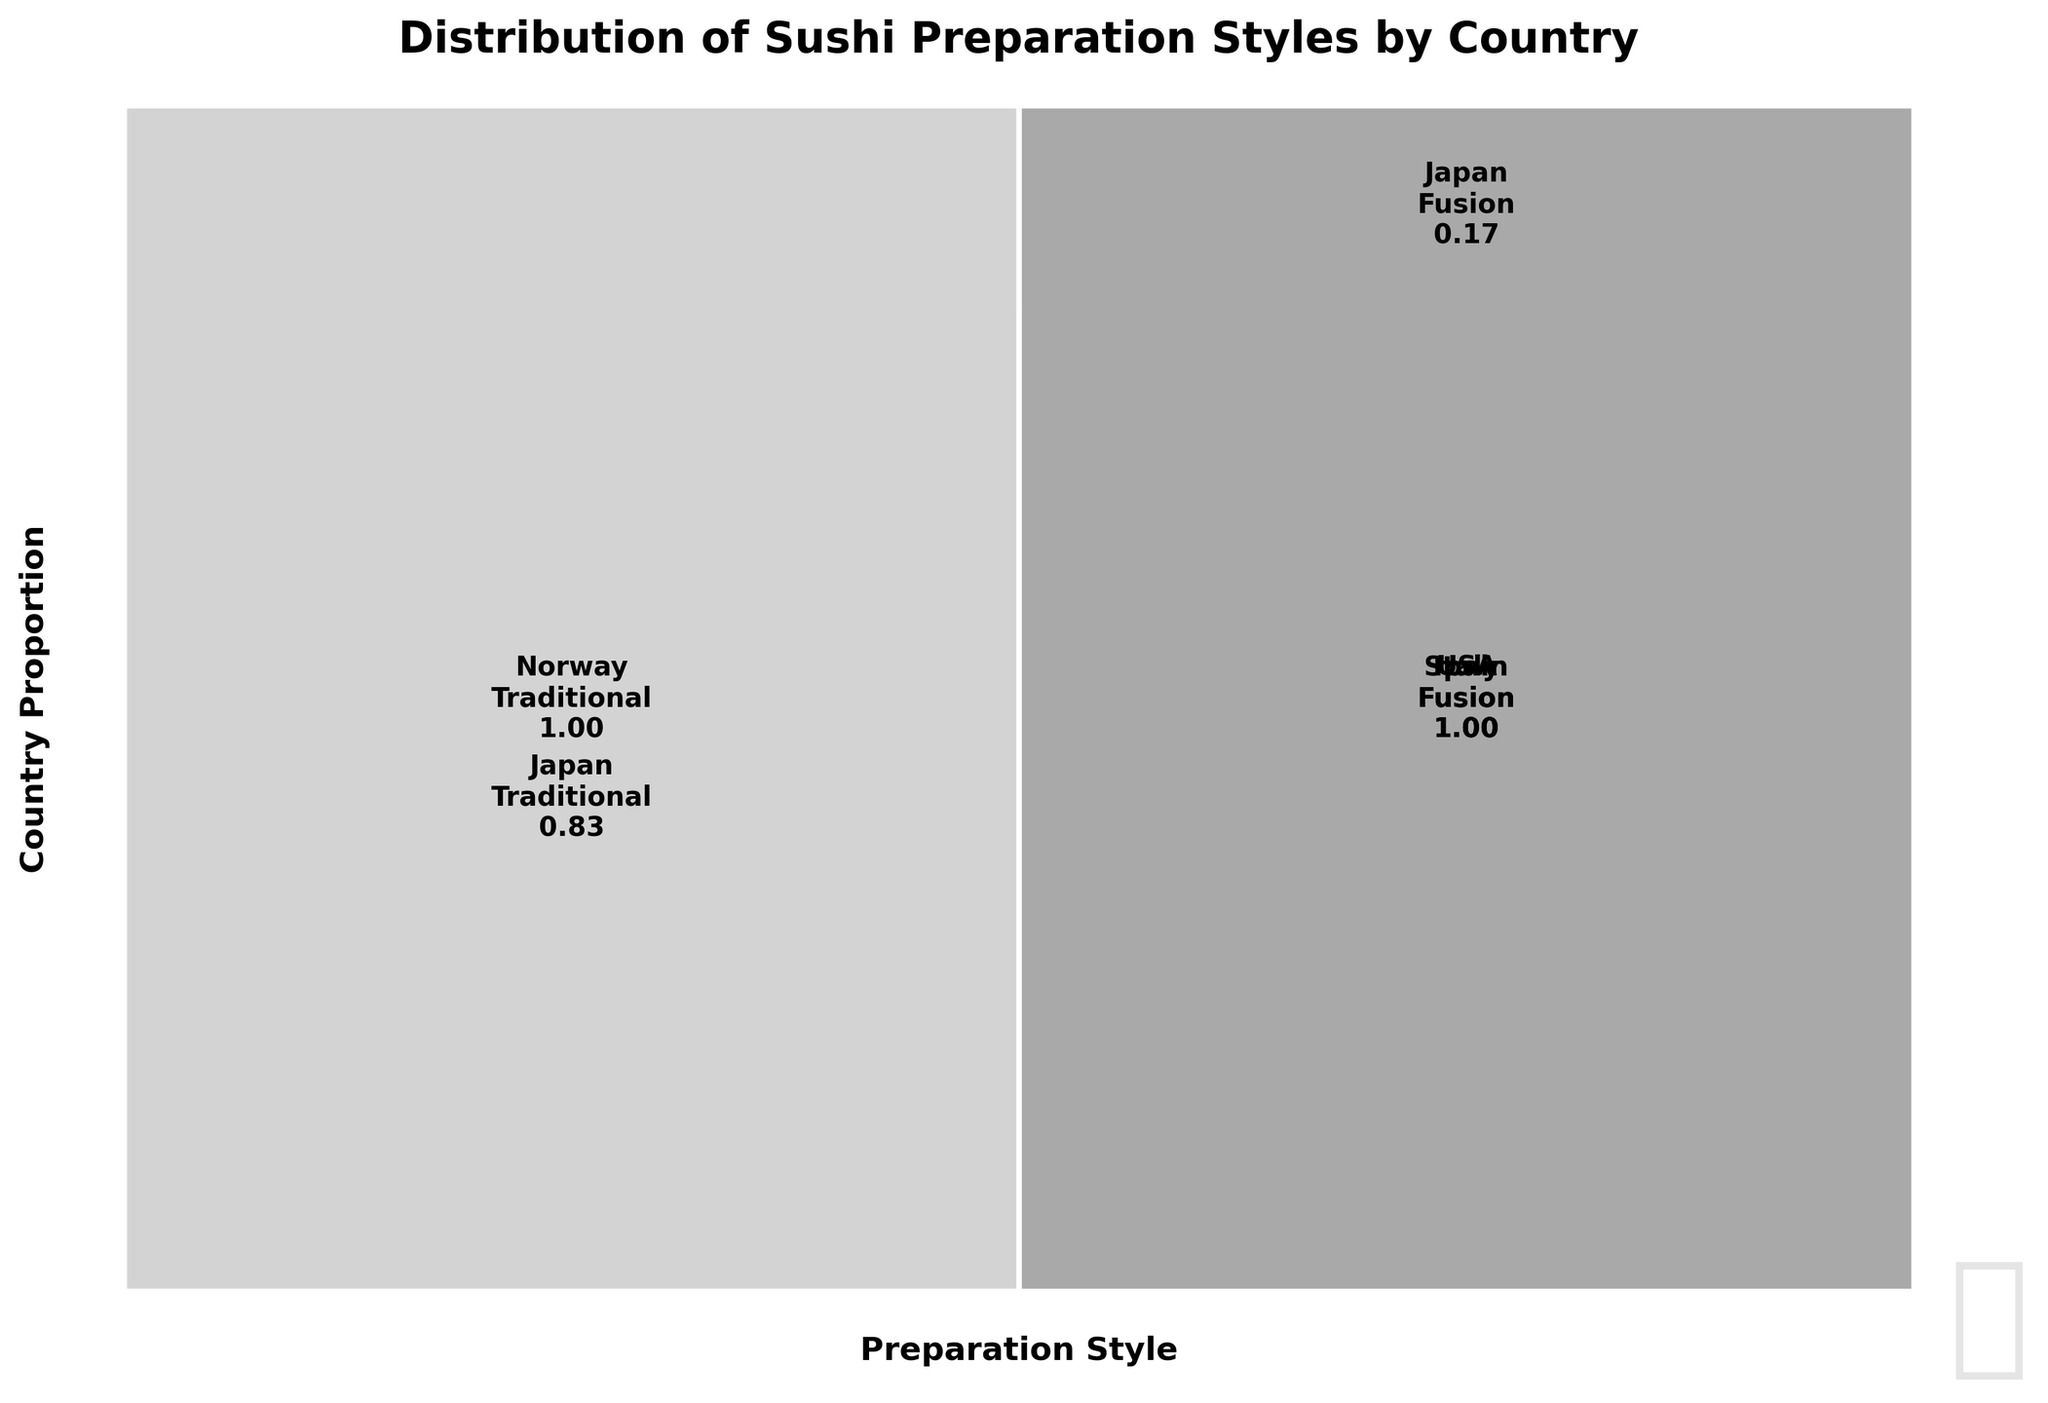What is the title of the plot? The title of the plot is located at the top of the figure. It summarizes what the figure represents.
Answer: Distribution of Sushi Preparation Styles by Country Which preparation style has larger proportions in Italy? Look at the rectangles in the Italy row. Compare the heights of the rectangles for Traditional and Fusion.
Answer: Fusion How do the proportions of Fusion preparation style compare between Japan and Italy? Look at the heights of the Fusion rectangles for Japan and Italy and compare them.
Answer: Japan has a larger Fusion proportion What is the approximate proportion of Traditional preparation style in Norway? Look at the height of the rectangle for Traditional in the Norway row and estimate its proportion.
Answer: 0.50 Which country has the smallest proportion of Fusion preparation style? Compare the heights of Fusion rectangles across all countries to find the smallest one.
Answer: Norway What is the total proportion of traditional preparation styles across all countries? Sum the heights of all the Traditional preparation rectangles.
Answer: 0.55 What is the difference in proportions between Traditional and Fusion preparation styles in Japan? Find the heights of Traditional and Fusion rectangles in the Japan row and calculate the difference.
Answer: 0.40 Which countries exhibit only Fusion preparation styles? Look at the countries on the x-axis and identify those that have only one type of rectangle, exclusively for Fusion.
Answer: USA, Spain How many countries show traditional preparation styles? Count the number of countries that have a rectangle for Traditional preparation style.
Answer: 4 countries Between Italy and Spain, which one has a higher proportion of Fusion preparation style? Compare the heights of the Fusion rectangles for Italy and Spain and determine which one is larger.
Answer: Italy 